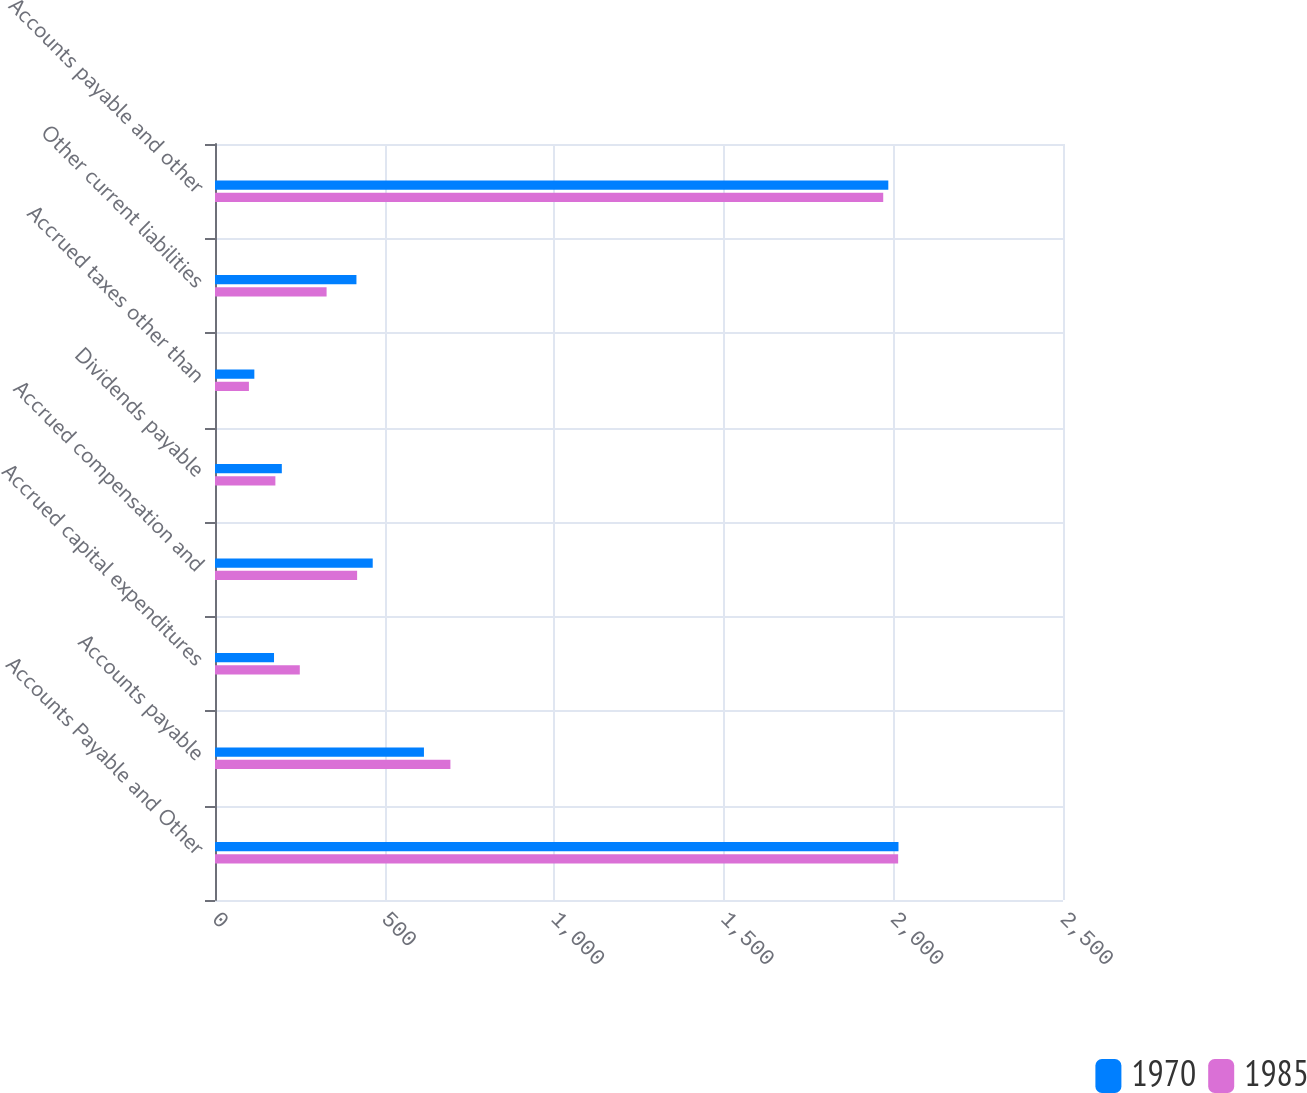Convert chart to OTSL. <chart><loc_0><loc_0><loc_500><loc_500><stacked_bar_chart><ecel><fcel>Accounts Payable and Other<fcel>Accounts payable<fcel>Accrued capital expenditures<fcel>Accrued compensation and<fcel>Dividends payable<fcel>Accrued taxes other than<fcel>Other current liabilities<fcel>Accounts payable and other<nl><fcel>1970<fcel>2015<fcel>616<fcel>174<fcel>465<fcel>197<fcel>116<fcel>417<fcel>1985<nl><fcel>1985<fcel>2014<fcel>694<fcel>250<fcel>419<fcel>178<fcel>100<fcel>329<fcel>1970<nl></chart> 